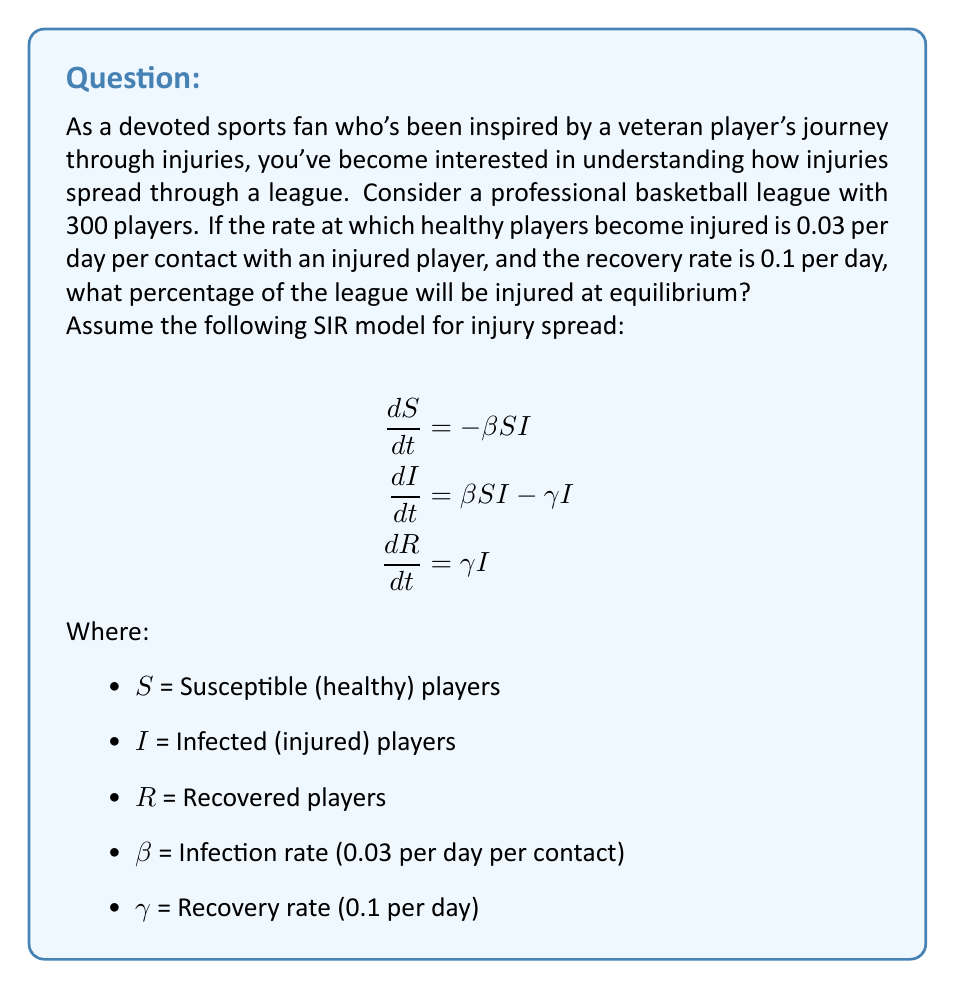Can you solve this math problem? Let's approach this step-by-step:

1) At equilibrium, the rate of change of infected players is zero:

   $$\frac{dI}{dt} = 0$$

2) This means:

   $$\beta SI - \gamma I = 0$$

3) We can factor out I:

   $$I(\beta S - \gamma) = 0$$

4) For this to be true (and assuming I is not zero), we must have:

   $$\beta S = \gamma$$

5) We can rearrange this to solve for S:

   $$S = \frac{\gamma}{\beta} = \frac{0.1}{0.03} \approx 3.33$$

6) This means that at equilibrium, there will be about 3.33 susceptible players for every infected player.

7) Let x be the fraction of infected players at equilibrium. Then:

   $$\frac{x}{1-x} = \frac{1}{3.33}$$

8) Solving for x:

   $$x = \frac{1}{4.33} \approx 0.2309$$

9) Convert to a percentage:

   $$0.2309 * 100\% \approx 23.09\%$$
Answer: 23.09% 